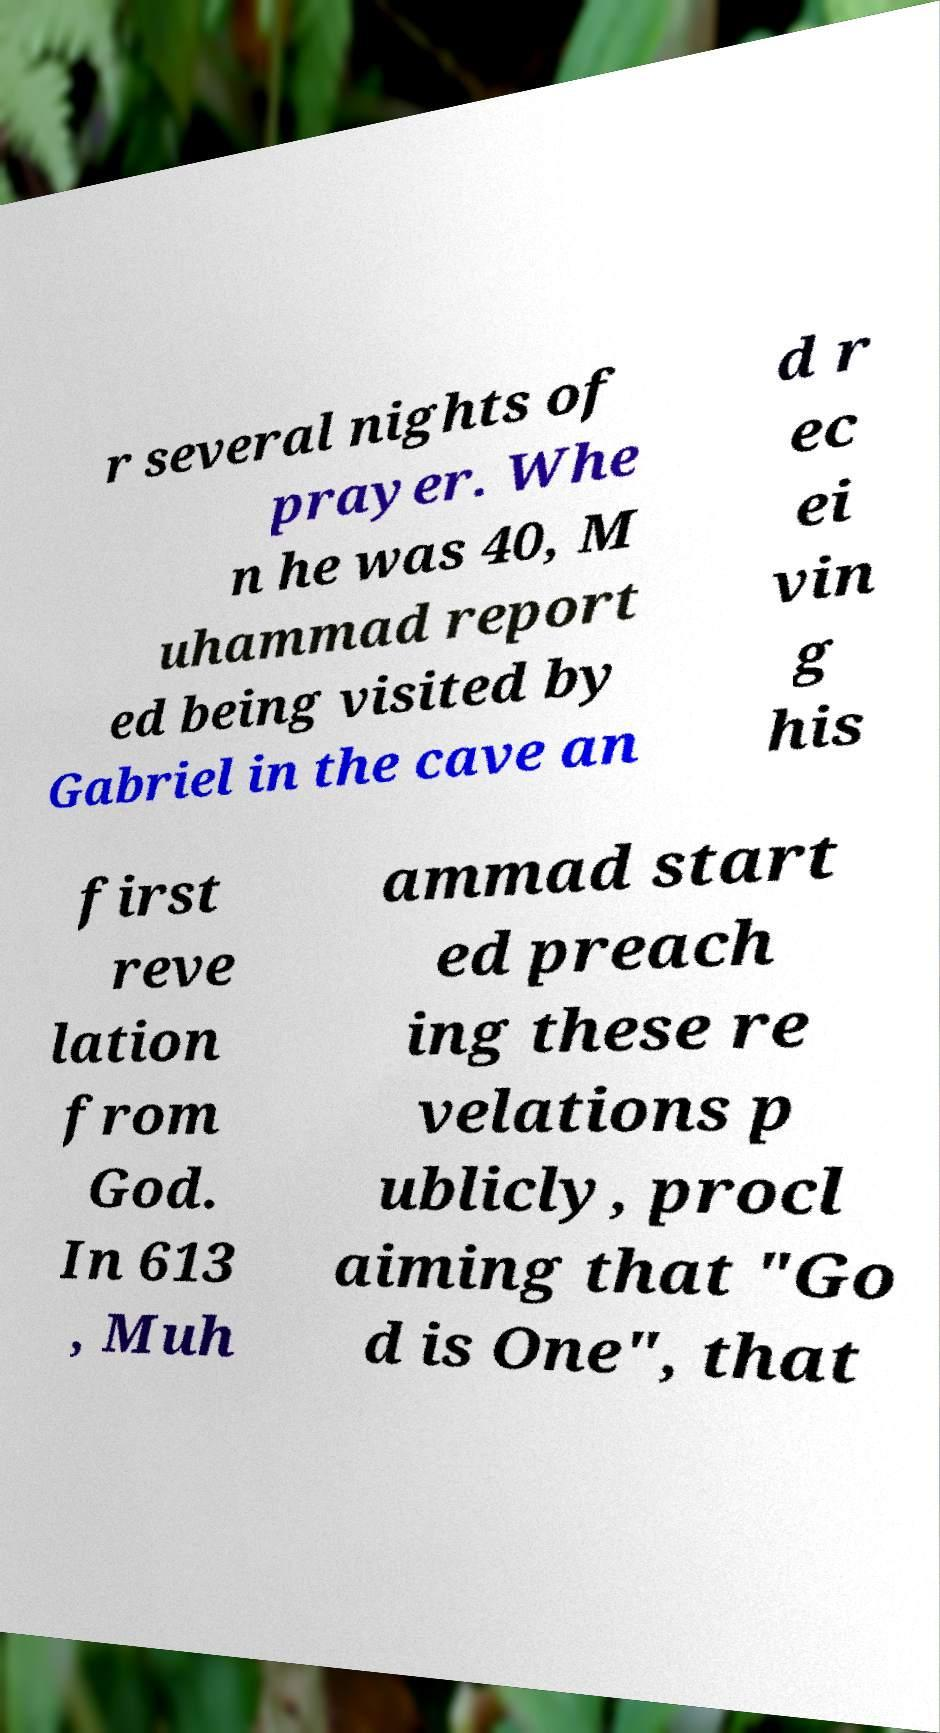Could you extract and type out the text from this image? r several nights of prayer. Whe n he was 40, M uhammad report ed being visited by Gabriel in the cave an d r ec ei vin g his first reve lation from God. In 613 , Muh ammad start ed preach ing these re velations p ublicly, procl aiming that "Go d is One", that 